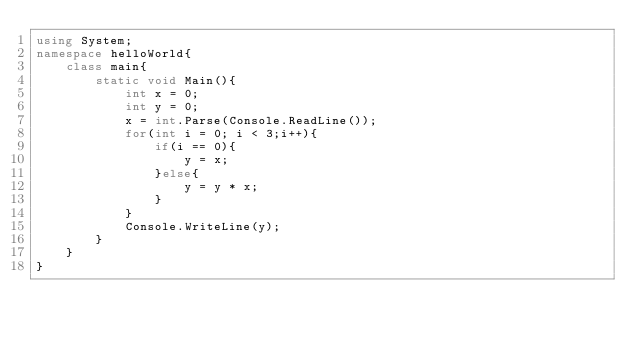<code> <loc_0><loc_0><loc_500><loc_500><_C#_>using System;
namespace helloWorld{
    class main{
        static void Main(){
            int x = 0;
            int y = 0;
            x = int.Parse(Console.ReadLine());
            for(int i = 0; i < 3;i++){
                if(i == 0){
                    y = x;
                }else{
                    y = y * x;
                }
            }
            Console.WriteLine(y);
        }
    }
}</code> 